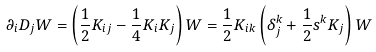<formula> <loc_0><loc_0><loc_500><loc_500>\partial _ { i } D _ { j } W = \left ( \frac { 1 } { 2 } K _ { i j } - \frac { 1 } { 4 } K _ { i } K _ { j } \right ) W = \frac { 1 } { 2 } K _ { i k } \left ( \delta ^ { k } _ { j } + \frac { 1 } { 2 } s ^ { k } K _ { j } \right ) W</formula> 